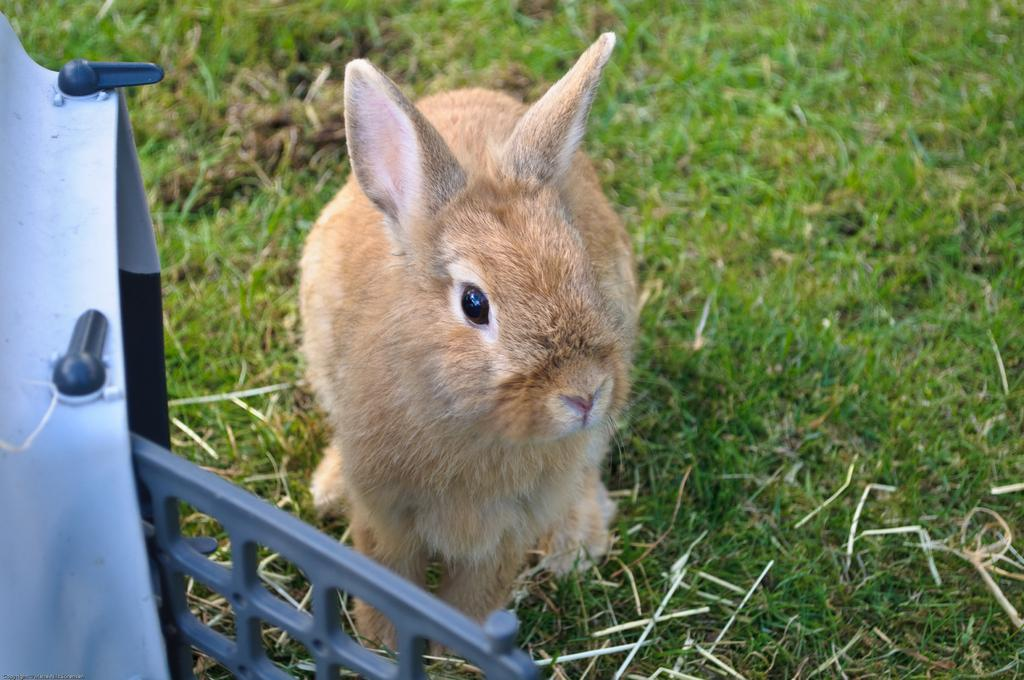What animal is in the center of the image? There is a rabbit in the center of the image. What is located on the left side of the image? There is a cage on the left side of the image. What type of vegetation is at the bottom of the image? There is grass at the bottom of the image. How does the rabbit measure the distance between the cage and the grass in the image? The rabbit does not measure the distance between the cage and the grass in the image; it is a static image and does not show any action or movement. 